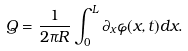Convert formula to latex. <formula><loc_0><loc_0><loc_500><loc_500>Q = \frac { 1 } { 2 \pi R } \int _ { 0 } ^ { L } \partial _ { x } \varphi ( x , t ) d x .</formula> 